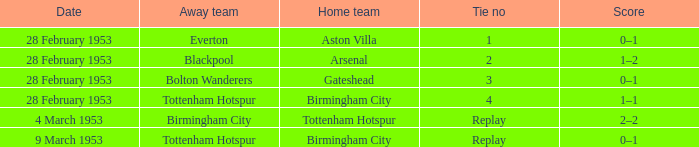Which Tie no has a Score of 0–1, and a Date of 9 march 1953? Replay. 